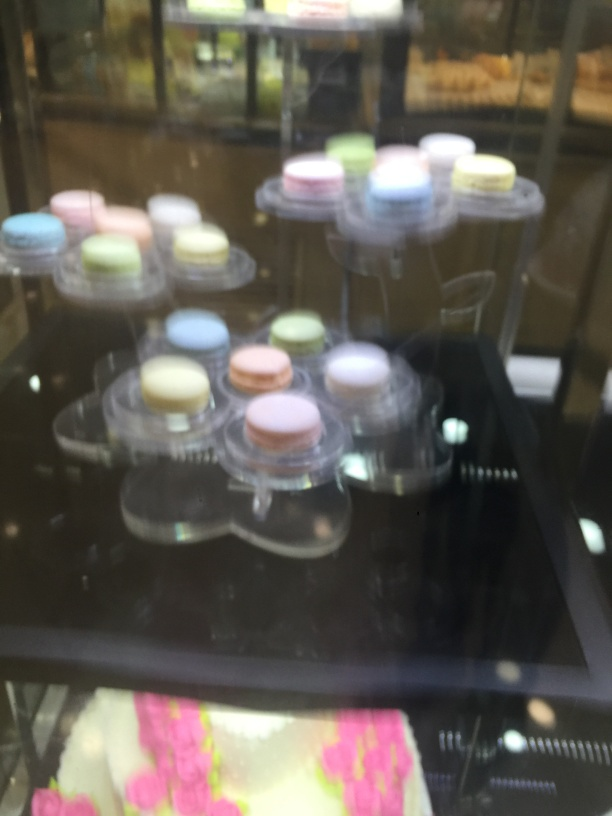Can you describe the setting where this photo was taken? The photograph appears to be taken in a bakery or café setting, focusing on a display case which typically houses desserts such as pastries or confections like macarons. The reflection and lighting suggest an indoor environment, possibly with a glass enclosure separating the treats from the customers. 